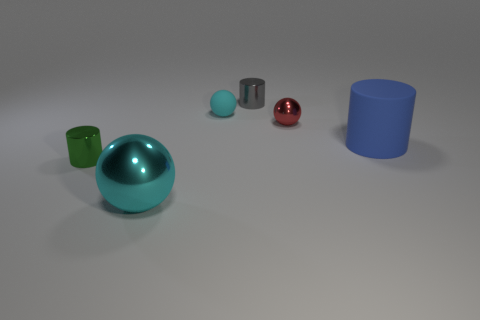What is the material of the other small thing that is the same shape as the small green thing?
Make the answer very short. Metal. Is the number of cyan matte objects greater than the number of gray metal cubes?
Ensure brevity in your answer.  Yes. What size is the metallic object that is both in front of the cyan rubber object and right of the large shiny ball?
Provide a short and direct response. Small. The gray thing is what shape?
Make the answer very short. Cylinder. What number of other small objects have the same shape as the small red object?
Make the answer very short. 1. Are there fewer large matte things that are behind the blue matte thing than cyan spheres that are in front of the big cyan metallic ball?
Ensure brevity in your answer.  No. There is a shiny sphere behind the blue thing; how many gray shiny cylinders are left of it?
Offer a terse response. 1. Is there a small red metal cylinder?
Offer a very short reply. No. Are there any big cyan balls made of the same material as the tiny green cylinder?
Give a very brief answer. Yes. Are there more big cyan balls to the left of the cyan matte thing than cyan metallic balls to the right of the gray thing?
Your answer should be compact. Yes. 